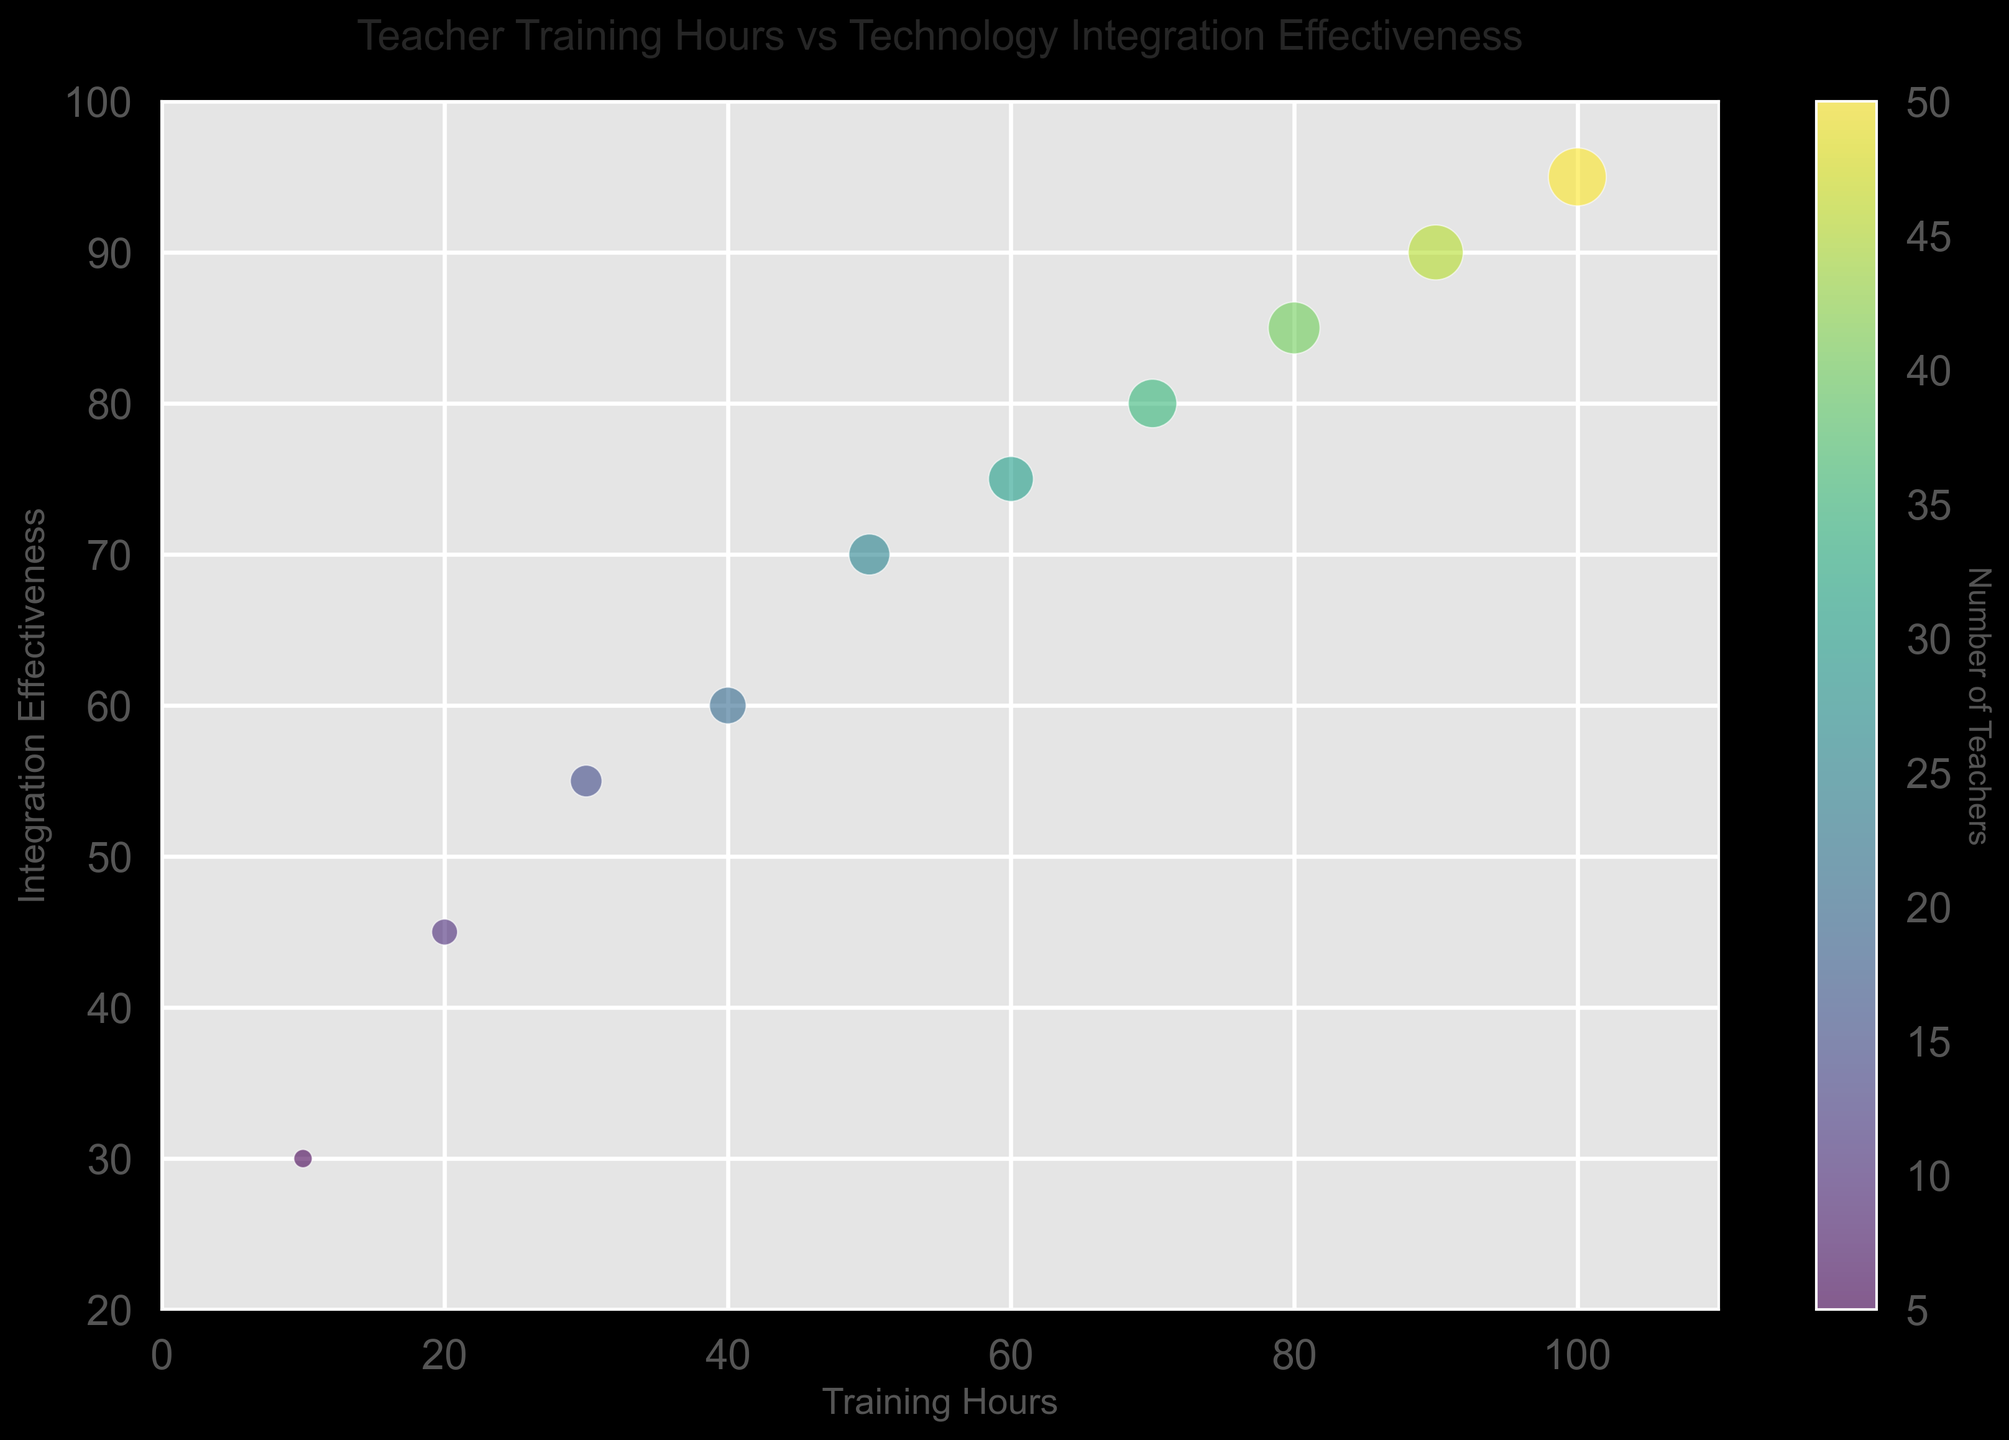What's the trend between training hours and integration effectiveness? As the training hours increase, the technology integration effectiveness also increases. This trend can be observed as the data points follow a positive slope from left to right in the bubble chart.
Answer: Positive trend What is the integration effectiveness for teachers with 60 training hours? Locate the bubble corresponding to 60 training hours on the x-axis, then check the integration effectiveness value on the y-axis for that bubble. The effectiveness is 75.
Answer: 75 Which group size has the highest integration effectiveness, and what is it? The largest bubble indicates the highest number of teachers. The largest bubble is at 100 training hours, with an integration effectiveness of 95.
Answer: 50 teachers, 95 What is the difference in integration effectiveness between teachers with 20 and 80 training hours? Locate the bubbles corresponding to 20 and 80 training hours. The effectiveness at 20 hours is 45, and at 80 hours, it is 85. The difference is 85 - 45 = 40.
Answer: 40 How many groups of teachers have an effectiveness of 70 or higher? Identify the bubbles with integration effectiveness values above 70. These bubbles correspond to training hours of 50, 60, 70, 80, 90, and 100. There are 6 such groups.
Answer: 6 Which color represents the highest number of teachers, and what is that number? The color bar helps in identifying the number of teachers corresponding to each color. The darkest color on the 'viridis' scale represents the highest number, which is 50 teachers at 100 training hours.
Answer: Darkest color, 50 What is the average integration effectiveness for training hours between 40 and 80? From the bubbles with training hours 40, 50, 60, 70, and 80, the effectiveness values are 60, 70, 75, 80, and 85. The average is (60 + 70 + 75 + 80 + 85) / 5 = 74.
Answer: 74 How does the size of the bubble change with an increasing number of teachers? The bubble size increases proportionally with the number of teachers, with larger bubbles representing more teachers.
Answer: Proportional increase Which group has a larger bubble, 10 training hours or 50 training hours? Compare the bubbles for 10 and 50 training hours. The bubble at 50 training hours is larger, indicating more teachers.
Answer: 50 training hours 